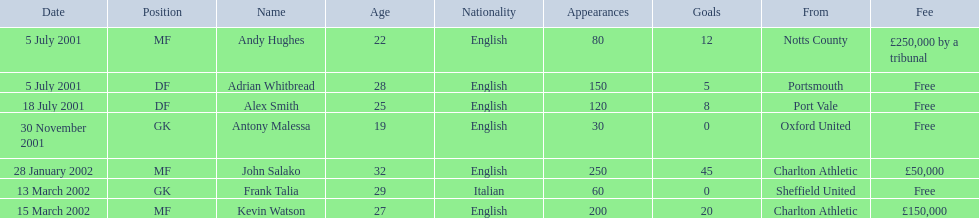List all the players names Andy Hughes, Adrian Whitbread, Alex Smith, Antony Malessa, John Salako, Frank Talia, Kevin Watson. Of these who is kevin watson Kevin Watson. To what transfer fee entry does kevin correspond to? £150,000. 